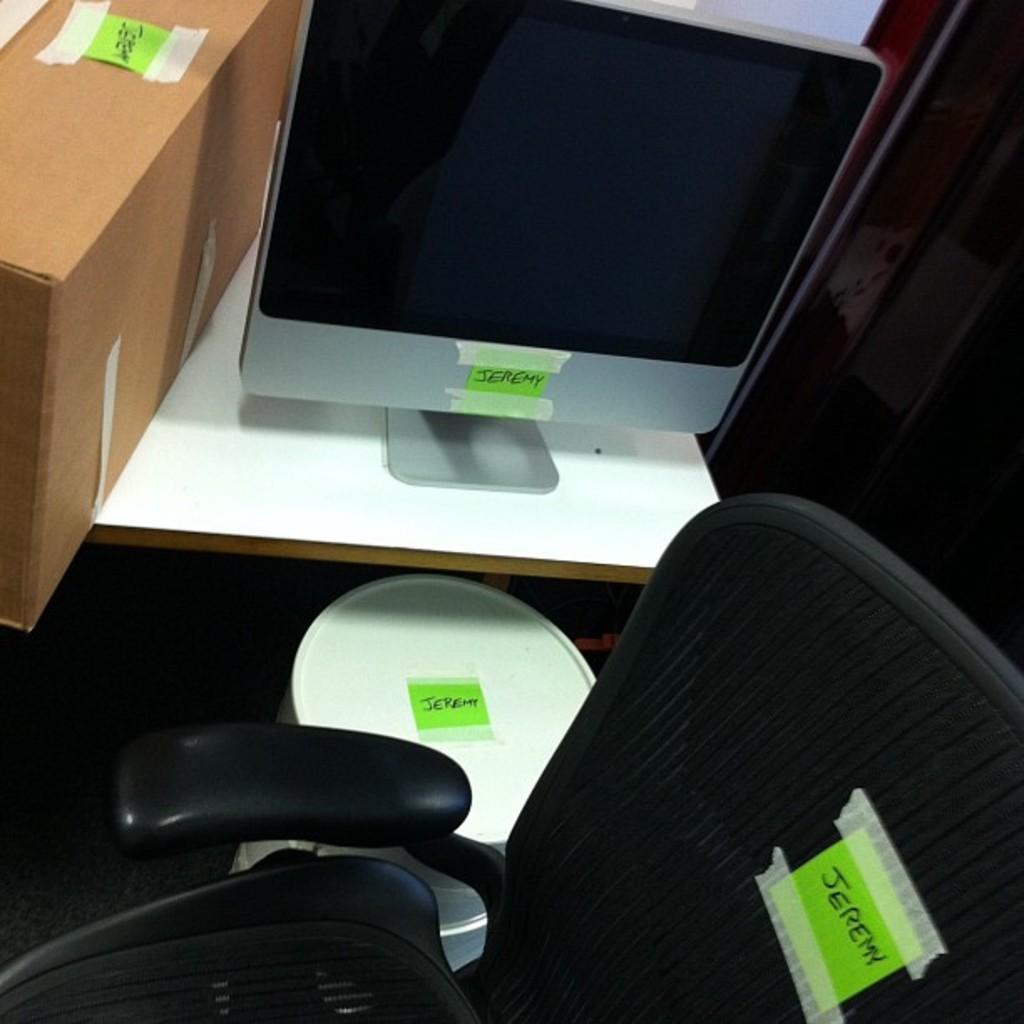Can you describe this image briefly? In this picture, there is a monitor on the table. At the bottom, there is a chair. In between them, there is a stool. Towards the top left, there is a box. On all the objects, there is a green paper with some text. 